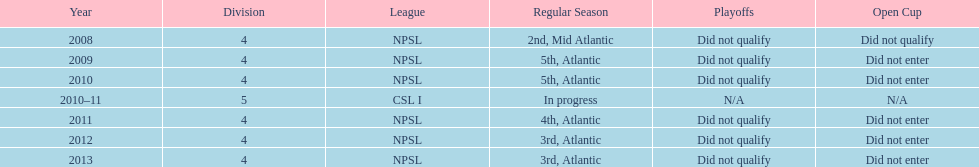In which year only did they compete in the fifth division? 2010-11. 